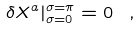<formula> <loc_0><loc_0><loc_500><loc_500>\delta X ^ { a } | ^ { \sigma = \pi } _ { \sigma = 0 } = 0 \ ,</formula> 